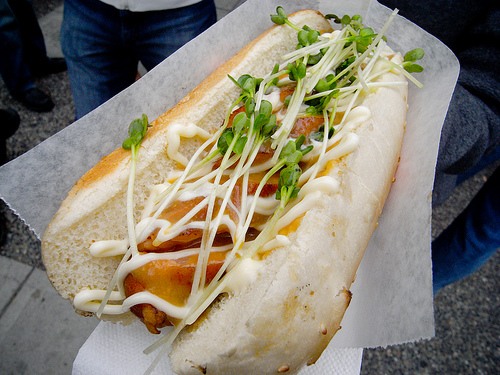<image>What kind of herb is on top of the sandwich? I don't know what kind of herb is on top of the sandwich. It could be parsley, chive, shallots, sprouts, or radish sprout. What kind of herb is on top of the sandwich? I don't know what kind of herb is on top of the sandwich. It can be parsley, chive, shallots, sprouts, cheese and leave, pepper, radish sprout, or parsley. 